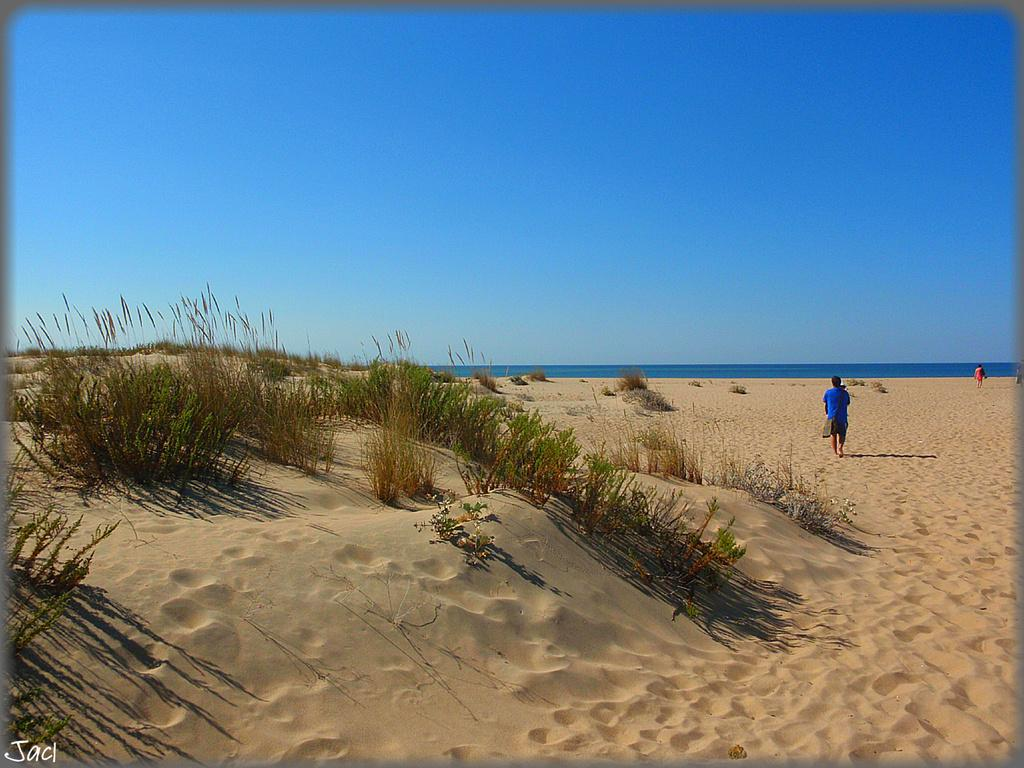What type of vegetation can be seen on the sand in the image? There is grass on the sand in the image. What are the two persons in the image doing? The two persons are walking on the sand. What can be seen in the background of the image? There is water and the sky visible in the background of the image. What type of cream is being used by the persons walking on the sand? There is no cream mentioned or visible in the image. What is the purpose of the cord in the image? There is no cord present in the image. 